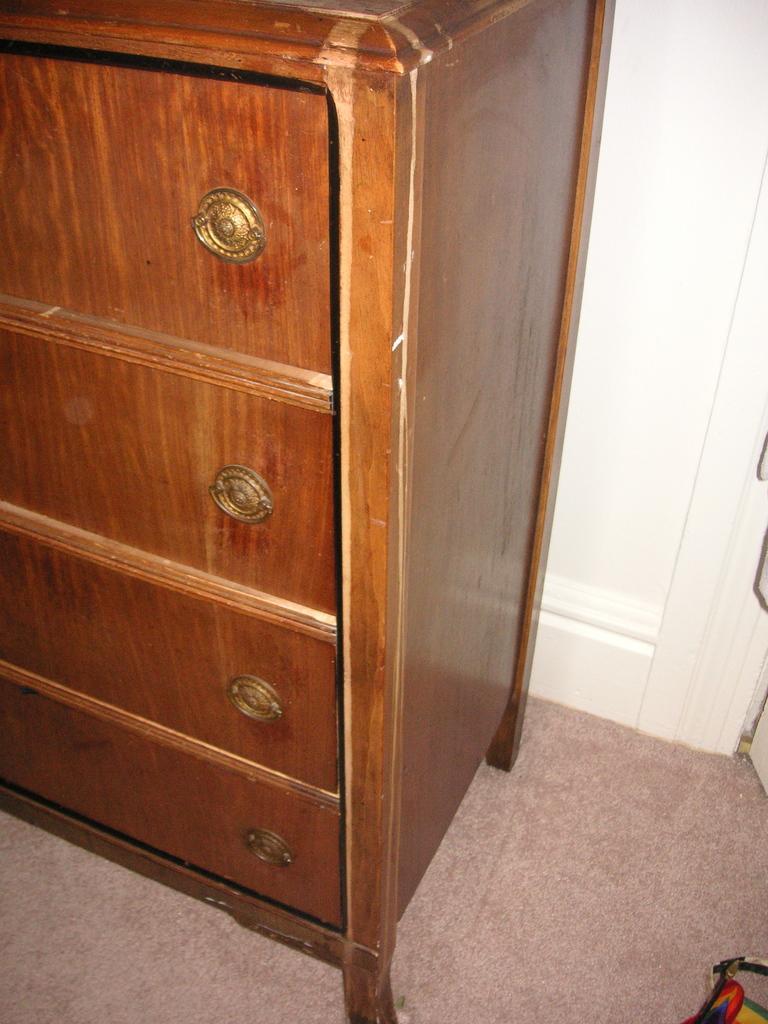Could you give a brief overview of what you see in this image? There is a wooden shelf. Near to that there is a wall. On the shelf there are round shaped golden objects. 